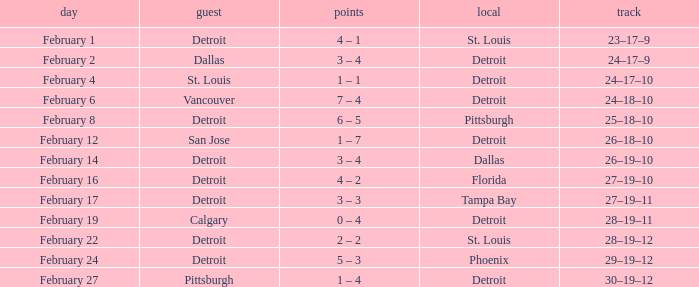What was their record on February 24? 29–19–12. 